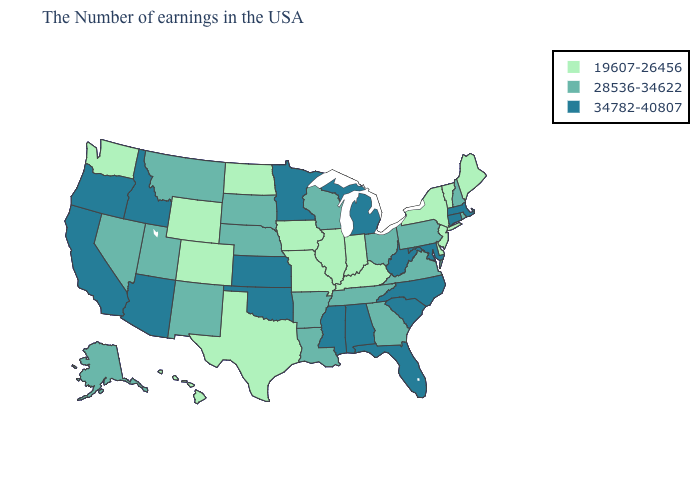What is the value of Alaska?
Short answer required. 28536-34622. What is the value of Tennessee?
Quick response, please. 28536-34622. Name the states that have a value in the range 19607-26456?
Short answer required. Maine, Vermont, New York, New Jersey, Delaware, Kentucky, Indiana, Illinois, Missouri, Iowa, Texas, North Dakota, Wyoming, Colorado, Washington, Hawaii. What is the lowest value in the MidWest?
Be succinct. 19607-26456. Does Hawaii have the same value as Wyoming?
Short answer required. Yes. How many symbols are there in the legend?
Keep it brief. 3. What is the value of Idaho?
Answer briefly. 34782-40807. How many symbols are there in the legend?
Be succinct. 3. What is the value of North Carolina?
Quick response, please. 34782-40807. Among the states that border Arkansas , does Mississippi have the highest value?
Answer briefly. Yes. Name the states that have a value in the range 34782-40807?
Be succinct. Massachusetts, Connecticut, Maryland, North Carolina, South Carolina, West Virginia, Florida, Michigan, Alabama, Mississippi, Minnesota, Kansas, Oklahoma, Arizona, Idaho, California, Oregon. What is the highest value in states that border North Carolina?
Give a very brief answer. 34782-40807. Does the first symbol in the legend represent the smallest category?
Keep it brief. Yes. Name the states that have a value in the range 34782-40807?
Write a very short answer. Massachusetts, Connecticut, Maryland, North Carolina, South Carolina, West Virginia, Florida, Michigan, Alabama, Mississippi, Minnesota, Kansas, Oklahoma, Arizona, Idaho, California, Oregon. 